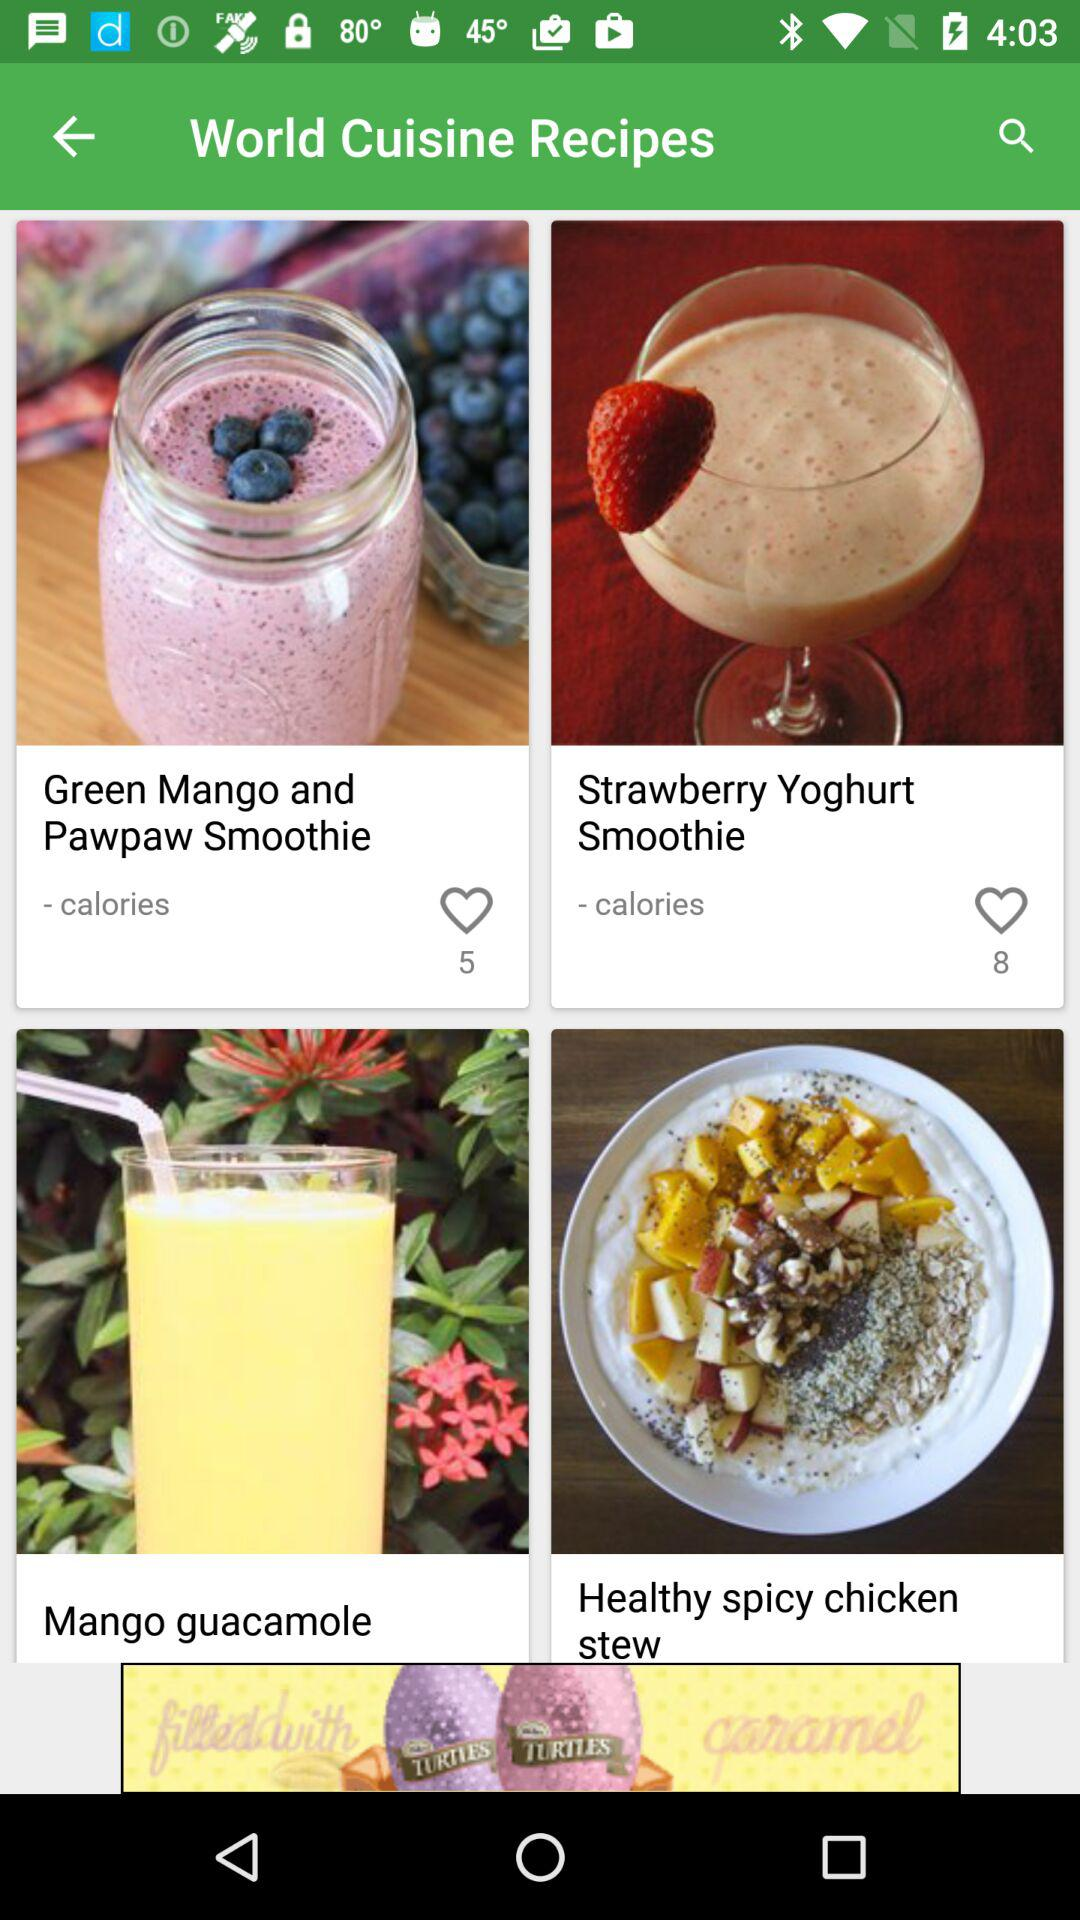How many people like the "Green Mango and Pawpaw Smoothie"? The number of people who like the "Green Mango and Pawpaw Smoothie" is 5. 